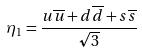<formula> <loc_0><loc_0><loc_500><loc_500>\eta _ { 1 } = \frac { u \overline { u } + d \overline { d } + s \overline { s } } { \sqrt { 3 } }</formula> 